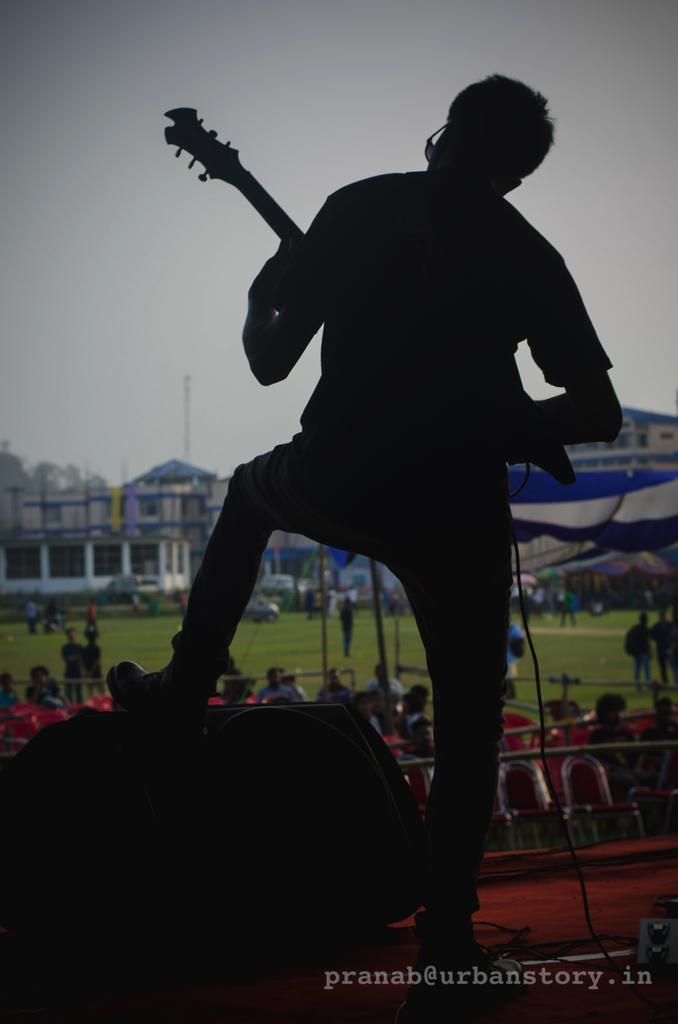What is the main subject of the image? There is a person in the image. What is the person doing in the image? The person is standing and holding a guitar. What can be seen in the background of the image? There is a building and the sky visible in the background of the image. What type of skirt is the committee wearing in the image? There is no committee or skirt present in the image. Can you describe the beetle that is playing the guitar in the image? There is no beetle present in the image; the person holding the guitar is human. 